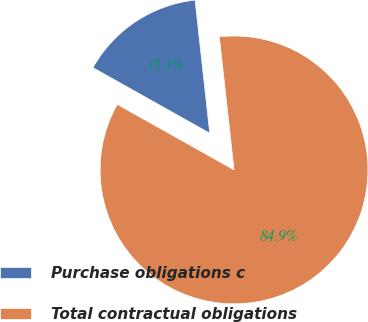<chart> <loc_0><loc_0><loc_500><loc_500><pie_chart><fcel>Purchase obligations c<fcel>Total contractual obligations<nl><fcel>15.11%<fcel>84.89%<nl></chart> 